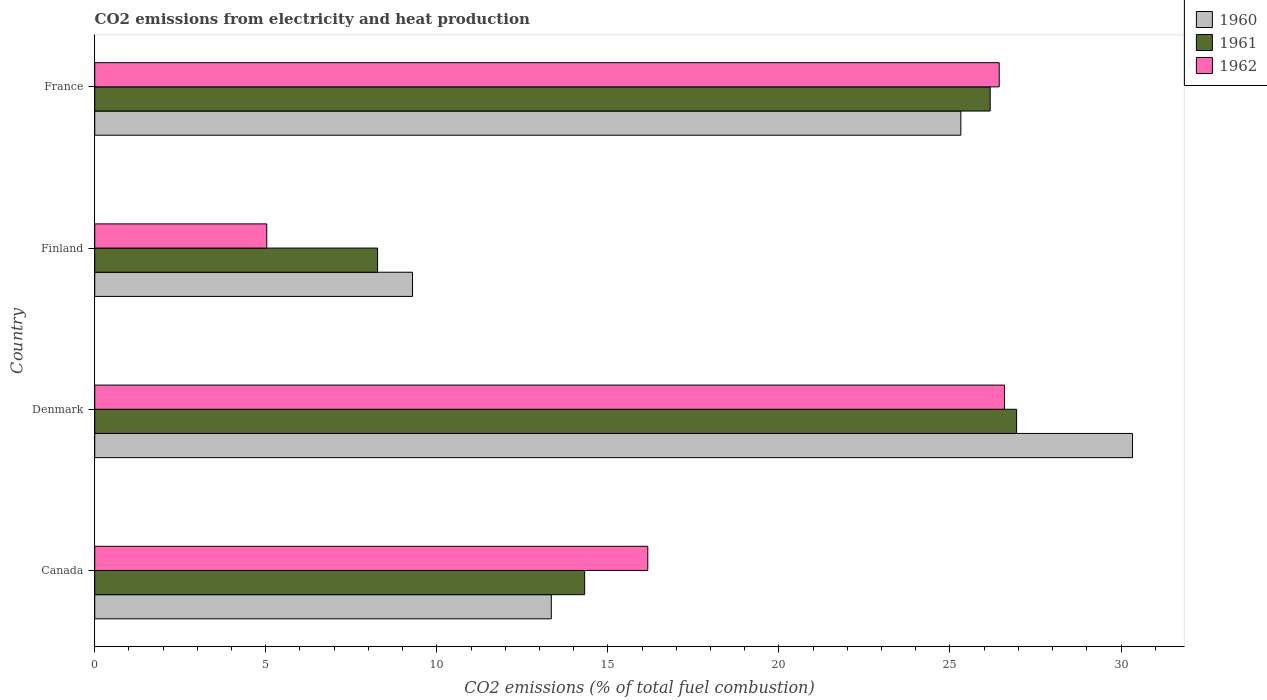Are the number of bars per tick equal to the number of legend labels?
Your answer should be compact. Yes. Are the number of bars on each tick of the Y-axis equal?
Make the answer very short. Yes. What is the amount of CO2 emitted in 1960 in Canada?
Give a very brief answer. 13.35. Across all countries, what is the maximum amount of CO2 emitted in 1962?
Provide a short and direct response. 26.59. Across all countries, what is the minimum amount of CO2 emitted in 1961?
Offer a terse response. 8.27. In which country was the amount of CO2 emitted in 1960 minimum?
Keep it short and to the point. Finland. What is the total amount of CO2 emitted in 1961 in the graph?
Ensure brevity in your answer.  75.71. What is the difference between the amount of CO2 emitted in 1960 in Denmark and that in France?
Ensure brevity in your answer.  5.02. What is the difference between the amount of CO2 emitted in 1961 in Denmark and the amount of CO2 emitted in 1960 in Finland?
Provide a short and direct response. 17.66. What is the average amount of CO2 emitted in 1960 per country?
Keep it short and to the point. 19.57. What is the difference between the amount of CO2 emitted in 1960 and amount of CO2 emitted in 1962 in Canada?
Keep it short and to the point. -2.82. What is the ratio of the amount of CO2 emitted in 1962 in Canada to that in Finland?
Your answer should be very brief. 3.22. Is the difference between the amount of CO2 emitted in 1960 in Denmark and Finland greater than the difference between the amount of CO2 emitted in 1962 in Denmark and Finland?
Your answer should be very brief. No. What is the difference between the highest and the second highest amount of CO2 emitted in 1960?
Your answer should be compact. 5.02. What is the difference between the highest and the lowest amount of CO2 emitted in 1961?
Your response must be concise. 18.68. Is the sum of the amount of CO2 emitted in 1961 in Denmark and France greater than the maximum amount of CO2 emitted in 1962 across all countries?
Your answer should be compact. Yes. What does the 1st bar from the top in Canada represents?
Make the answer very short. 1962. What does the 1st bar from the bottom in Denmark represents?
Make the answer very short. 1960. How many countries are there in the graph?
Ensure brevity in your answer.  4. Are the values on the major ticks of X-axis written in scientific E-notation?
Offer a terse response. No. Does the graph contain any zero values?
Offer a very short reply. No. Where does the legend appear in the graph?
Keep it short and to the point. Top right. How many legend labels are there?
Offer a very short reply. 3. What is the title of the graph?
Keep it short and to the point. CO2 emissions from electricity and heat production. Does "2012" appear as one of the legend labels in the graph?
Keep it short and to the point. No. What is the label or title of the X-axis?
Keep it short and to the point. CO2 emissions (% of total fuel combustion). What is the label or title of the Y-axis?
Your response must be concise. Country. What is the CO2 emissions (% of total fuel combustion) of 1960 in Canada?
Offer a very short reply. 13.35. What is the CO2 emissions (% of total fuel combustion) in 1961 in Canada?
Provide a short and direct response. 14.32. What is the CO2 emissions (% of total fuel combustion) in 1962 in Canada?
Keep it short and to the point. 16.17. What is the CO2 emissions (% of total fuel combustion) in 1960 in Denmark?
Provide a short and direct response. 30.34. What is the CO2 emissions (% of total fuel combustion) in 1961 in Denmark?
Your response must be concise. 26.95. What is the CO2 emissions (% of total fuel combustion) of 1962 in Denmark?
Ensure brevity in your answer.  26.59. What is the CO2 emissions (% of total fuel combustion) in 1960 in Finland?
Provide a succinct answer. 9.29. What is the CO2 emissions (% of total fuel combustion) in 1961 in Finland?
Give a very brief answer. 8.27. What is the CO2 emissions (% of total fuel combustion) of 1962 in Finland?
Provide a short and direct response. 5.03. What is the CO2 emissions (% of total fuel combustion) of 1960 in France?
Your response must be concise. 25.32. What is the CO2 emissions (% of total fuel combustion) of 1961 in France?
Your response must be concise. 26.18. What is the CO2 emissions (% of total fuel combustion) in 1962 in France?
Provide a short and direct response. 26.44. Across all countries, what is the maximum CO2 emissions (% of total fuel combustion) of 1960?
Make the answer very short. 30.34. Across all countries, what is the maximum CO2 emissions (% of total fuel combustion) of 1961?
Your answer should be compact. 26.95. Across all countries, what is the maximum CO2 emissions (% of total fuel combustion) in 1962?
Ensure brevity in your answer.  26.59. Across all countries, what is the minimum CO2 emissions (% of total fuel combustion) of 1960?
Offer a terse response. 9.29. Across all countries, what is the minimum CO2 emissions (% of total fuel combustion) in 1961?
Make the answer very short. 8.27. Across all countries, what is the minimum CO2 emissions (% of total fuel combustion) of 1962?
Keep it short and to the point. 5.03. What is the total CO2 emissions (% of total fuel combustion) in 1960 in the graph?
Offer a very short reply. 78.29. What is the total CO2 emissions (% of total fuel combustion) of 1961 in the graph?
Offer a very short reply. 75.71. What is the total CO2 emissions (% of total fuel combustion) in 1962 in the graph?
Give a very brief answer. 74.23. What is the difference between the CO2 emissions (% of total fuel combustion) of 1960 in Canada and that in Denmark?
Offer a terse response. -16.99. What is the difference between the CO2 emissions (% of total fuel combustion) in 1961 in Canada and that in Denmark?
Your answer should be very brief. -12.63. What is the difference between the CO2 emissions (% of total fuel combustion) in 1962 in Canada and that in Denmark?
Offer a terse response. -10.43. What is the difference between the CO2 emissions (% of total fuel combustion) of 1960 in Canada and that in Finland?
Keep it short and to the point. 4.06. What is the difference between the CO2 emissions (% of total fuel combustion) of 1961 in Canada and that in Finland?
Keep it short and to the point. 6.05. What is the difference between the CO2 emissions (% of total fuel combustion) of 1962 in Canada and that in Finland?
Give a very brief answer. 11.14. What is the difference between the CO2 emissions (% of total fuel combustion) in 1960 in Canada and that in France?
Your response must be concise. -11.97. What is the difference between the CO2 emissions (% of total fuel combustion) in 1961 in Canada and that in France?
Offer a terse response. -11.85. What is the difference between the CO2 emissions (% of total fuel combustion) of 1962 in Canada and that in France?
Your response must be concise. -10.27. What is the difference between the CO2 emissions (% of total fuel combustion) of 1960 in Denmark and that in Finland?
Keep it short and to the point. 21.05. What is the difference between the CO2 emissions (% of total fuel combustion) in 1961 in Denmark and that in Finland?
Offer a terse response. 18.68. What is the difference between the CO2 emissions (% of total fuel combustion) in 1962 in Denmark and that in Finland?
Keep it short and to the point. 21.57. What is the difference between the CO2 emissions (% of total fuel combustion) of 1960 in Denmark and that in France?
Provide a succinct answer. 5.02. What is the difference between the CO2 emissions (% of total fuel combustion) of 1961 in Denmark and that in France?
Your answer should be compact. 0.77. What is the difference between the CO2 emissions (% of total fuel combustion) of 1962 in Denmark and that in France?
Ensure brevity in your answer.  0.15. What is the difference between the CO2 emissions (% of total fuel combustion) in 1960 in Finland and that in France?
Offer a very short reply. -16.03. What is the difference between the CO2 emissions (% of total fuel combustion) of 1961 in Finland and that in France?
Provide a short and direct response. -17.91. What is the difference between the CO2 emissions (% of total fuel combustion) of 1962 in Finland and that in France?
Your response must be concise. -21.41. What is the difference between the CO2 emissions (% of total fuel combustion) in 1960 in Canada and the CO2 emissions (% of total fuel combustion) in 1961 in Denmark?
Your answer should be compact. -13.6. What is the difference between the CO2 emissions (% of total fuel combustion) of 1960 in Canada and the CO2 emissions (% of total fuel combustion) of 1962 in Denmark?
Make the answer very short. -13.25. What is the difference between the CO2 emissions (% of total fuel combustion) of 1961 in Canada and the CO2 emissions (% of total fuel combustion) of 1962 in Denmark?
Keep it short and to the point. -12.27. What is the difference between the CO2 emissions (% of total fuel combustion) of 1960 in Canada and the CO2 emissions (% of total fuel combustion) of 1961 in Finland?
Offer a very short reply. 5.08. What is the difference between the CO2 emissions (% of total fuel combustion) in 1960 in Canada and the CO2 emissions (% of total fuel combustion) in 1962 in Finland?
Provide a succinct answer. 8.32. What is the difference between the CO2 emissions (% of total fuel combustion) in 1961 in Canada and the CO2 emissions (% of total fuel combustion) in 1962 in Finland?
Provide a short and direct response. 9.29. What is the difference between the CO2 emissions (% of total fuel combustion) in 1960 in Canada and the CO2 emissions (% of total fuel combustion) in 1961 in France?
Give a very brief answer. -12.83. What is the difference between the CO2 emissions (% of total fuel combustion) of 1960 in Canada and the CO2 emissions (% of total fuel combustion) of 1962 in France?
Make the answer very short. -13.09. What is the difference between the CO2 emissions (% of total fuel combustion) in 1961 in Canada and the CO2 emissions (% of total fuel combustion) in 1962 in France?
Provide a succinct answer. -12.12. What is the difference between the CO2 emissions (% of total fuel combustion) of 1960 in Denmark and the CO2 emissions (% of total fuel combustion) of 1961 in Finland?
Ensure brevity in your answer.  22.07. What is the difference between the CO2 emissions (% of total fuel combustion) in 1960 in Denmark and the CO2 emissions (% of total fuel combustion) in 1962 in Finland?
Make the answer very short. 25.31. What is the difference between the CO2 emissions (% of total fuel combustion) in 1961 in Denmark and the CO2 emissions (% of total fuel combustion) in 1962 in Finland?
Offer a terse response. 21.92. What is the difference between the CO2 emissions (% of total fuel combustion) in 1960 in Denmark and the CO2 emissions (% of total fuel combustion) in 1961 in France?
Ensure brevity in your answer.  4.16. What is the difference between the CO2 emissions (% of total fuel combustion) in 1960 in Denmark and the CO2 emissions (% of total fuel combustion) in 1962 in France?
Provide a succinct answer. 3.9. What is the difference between the CO2 emissions (% of total fuel combustion) of 1961 in Denmark and the CO2 emissions (% of total fuel combustion) of 1962 in France?
Keep it short and to the point. 0.51. What is the difference between the CO2 emissions (% of total fuel combustion) of 1960 in Finland and the CO2 emissions (% of total fuel combustion) of 1961 in France?
Keep it short and to the point. -16.89. What is the difference between the CO2 emissions (% of total fuel combustion) of 1960 in Finland and the CO2 emissions (% of total fuel combustion) of 1962 in France?
Your answer should be very brief. -17.15. What is the difference between the CO2 emissions (% of total fuel combustion) in 1961 in Finland and the CO2 emissions (% of total fuel combustion) in 1962 in France?
Make the answer very short. -18.17. What is the average CO2 emissions (% of total fuel combustion) in 1960 per country?
Ensure brevity in your answer.  19.57. What is the average CO2 emissions (% of total fuel combustion) of 1961 per country?
Offer a terse response. 18.93. What is the average CO2 emissions (% of total fuel combustion) of 1962 per country?
Give a very brief answer. 18.56. What is the difference between the CO2 emissions (% of total fuel combustion) of 1960 and CO2 emissions (% of total fuel combustion) of 1961 in Canada?
Offer a terse response. -0.98. What is the difference between the CO2 emissions (% of total fuel combustion) of 1960 and CO2 emissions (% of total fuel combustion) of 1962 in Canada?
Your answer should be compact. -2.82. What is the difference between the CO2 emissions (% of total fuel combustion) in 1961 and CO2 emissions (% of total fuel combustion) in 1962 in Canada?
Offer a terse response. -1.85. What is the difference between the CO2 emissions (% of total fuel combustion) of 1960 and CO2 emissions (% of total fuel combustion) of 1961 in Denmark?
Offer a very short reply. 3.39. What is the difference between the CO2 emissions (% of total fuel combustion) in 1960 and CO2 emissions (% of total fuel combustion) in 1962 in Denmark?
Your answer should be compact. 3.74. What is the difference between the CO2 emissions (% of total fuel combustion) in 1961 and CO2 emissions (% of total fuel combustion) in 1962 in Denmark?
Make the answer very short. 0.35. What is the difference between the CO2 emissions (% of total fuel combustion) in 1960 and CO2 emissions (% of total fuel combustion) in 1961 in Finland?
Make the answer very short. 1.02. What is the difference between the CO2 emissions (% of total fuel combustion) of 1960 and CO2 emissions (% of total fuel combustion) of 1962 in Finland?
Your answer should be very brief. 4.26. What is the difference between the CO2 emissions (% of total fuel combustion) in 1961 and CO2 emissions (% of total fuel combustion) in 1962 in Finland?
Provide a succinct answer. 3.24. What is the difference between the CO2 emissions (% of total fuel combustion) in 1960 and CO2 emissions (% of total fuel combustion) in 1961 in France?
Your response must be concise. -0.86. What is the difference between the CO2 emissions (% of total fuel combustion) of 1960 and CO2 emissions (% of total fuel combustion) of 1962 in France?
Make the answer very short. -1.12. What is the difference between the CO2 emissions (% of total fuel combustion) in 1961 and CO2 emissions (% of total fuel combustion) in 1962 in France?
Keep it short and to the point. -0.26. What is the ratio of the CO2 emissions (% of total fuel combustion) of 1960 in Canada to that in Denmark?
Keep it short and to the point. 0.44. What is the ratio of the CO2 emissions (% of total fuel combustion) of 1961 in Canada to that in Denmark?
Offer a terse response. 0.53. What is the ratio of the CO2 emissions (% of total fuel combustion) in 1962 in Canada to that in Denmark?
Offer a terse response. 0.61. What is the ratio of the CO2 emissions (% of total fuel combustion) in 1960 in Canada to that in Finland?
Offer a very short reply. 1.44. What is the ratio of the CO2 emissions (% of total fuel combustion) of 1961 in Canada to that in Finland?
Offer a terse response. 1.73. What is the ratio of the CO2 emissions (% of total fuel combustion) in 1962 in Canada to that in Finland?
Your answer should be very brief. 3.22. What is the ratio of the CO2 emissions (% of total fuel combustion) of 1960 in Canada to that in France?
Offer a very short reply. 0.53. What is the ratio of the CO2 emissions (% of total fuel combustion) in 1961 in Canada to that in France?
Ensure brevity in your answer.  0.55. What is the ratio of the CO2 emissions (% of total fuel combustion) of 1962 in Canada to that in France?
Provide a succinct answer. 0.61. What is the ratio of the CO2 emissions (% of total fuel combustion) of 1960 in Denmark to that in Finland?
Offer a terse response. 3.27. What is the ratio of the CO2 emissions (% of total fuel combustion) in 1961 in Denmark to that in Finland?
Keep it short and to the point. 3.26. What is the ratio of the CO2 emissions (% of total fuel combustion) of 1962 in Denmark to that in Finland?
Ensure brevity in your answer.  5.29. What is the ratio of the CO2 emissions (% of total fuel combustion) in 1960 in Denmark to that in France?
Ensure brevity in your answer.  1.2. What is the ratio of the CO2 emissions (% of total fuel combustion) in 1961 in Denmark to that in France?
Give a very brief answer. 1.03. What is the ratio of the CO2 emissions (% of total fuel combustion) in 1960 in Finland to that in France?
Provide a succinct answer. 0.37. What is the ratio of the CO2 emissions (% of total fuel combustion) in 1961 in Finland to that in France?
Offer a very short reply. 0.32. What is the ratio of the CO2 emissions (% of total fuel combustion) in 1962 in Finland to that in France?
Provide a succinct answer. 0.19. What is the difference between the highest and the second highest CO2 emissions (% of total fuel combustion) of 1960?
Make the answer very short. 5.02. What is the difference between the highest and the second highest CO2 emissions (% of total fuel combustion) of 1961?
Your answer should be compact. 0.77. What is the difference between the highest and the second highest CO2 emissions (% of total fuel combustion) of 1962?
Your response must be concise. 0.15. What is the difference between the highest and the lowest CO2 emissions (% of total fuel combustion) of 1960?
Make the answer very short. 21.05. What is the difference between the highest and the lowest CO2 emissions (% of total fuel combustion) in 1961?
Give a very brief answer. 18.68. What is the difference between the highest and the lowest CO2 emissions (% of total fuel combustion) of 1962?
Offer a terse response. 21.57. 